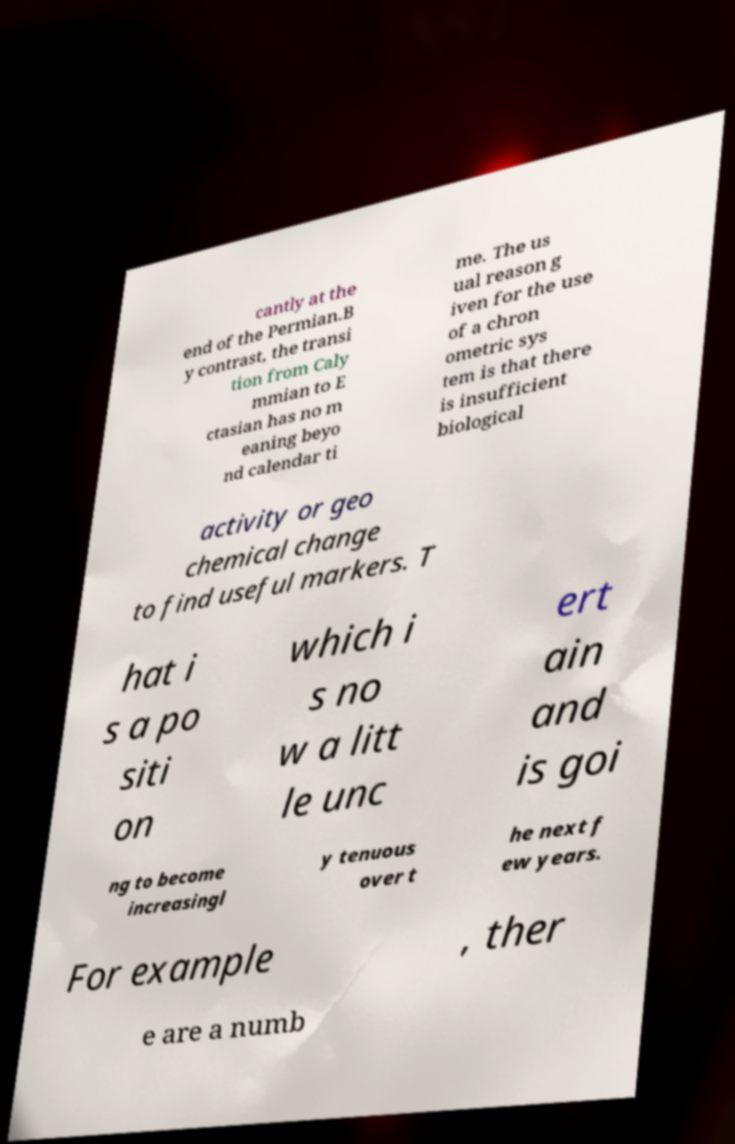Please identify and transcribe the text found in this image. cantly at the end of the Permian.B y contrast, the transi tion from Caly mmian to E ctasian has no m eaning beyo nd calendar ti me. The us ual reason g iven for the use of a chron ometric sys tem is that there is insufficient biological activity or geo chemical change to find useful markers. T hat i s a po siti on which i s no w a litt le unc ert ain and is goi ng to become increasingl y tenuous over t he next f ew years. For example , ther e are a numb 